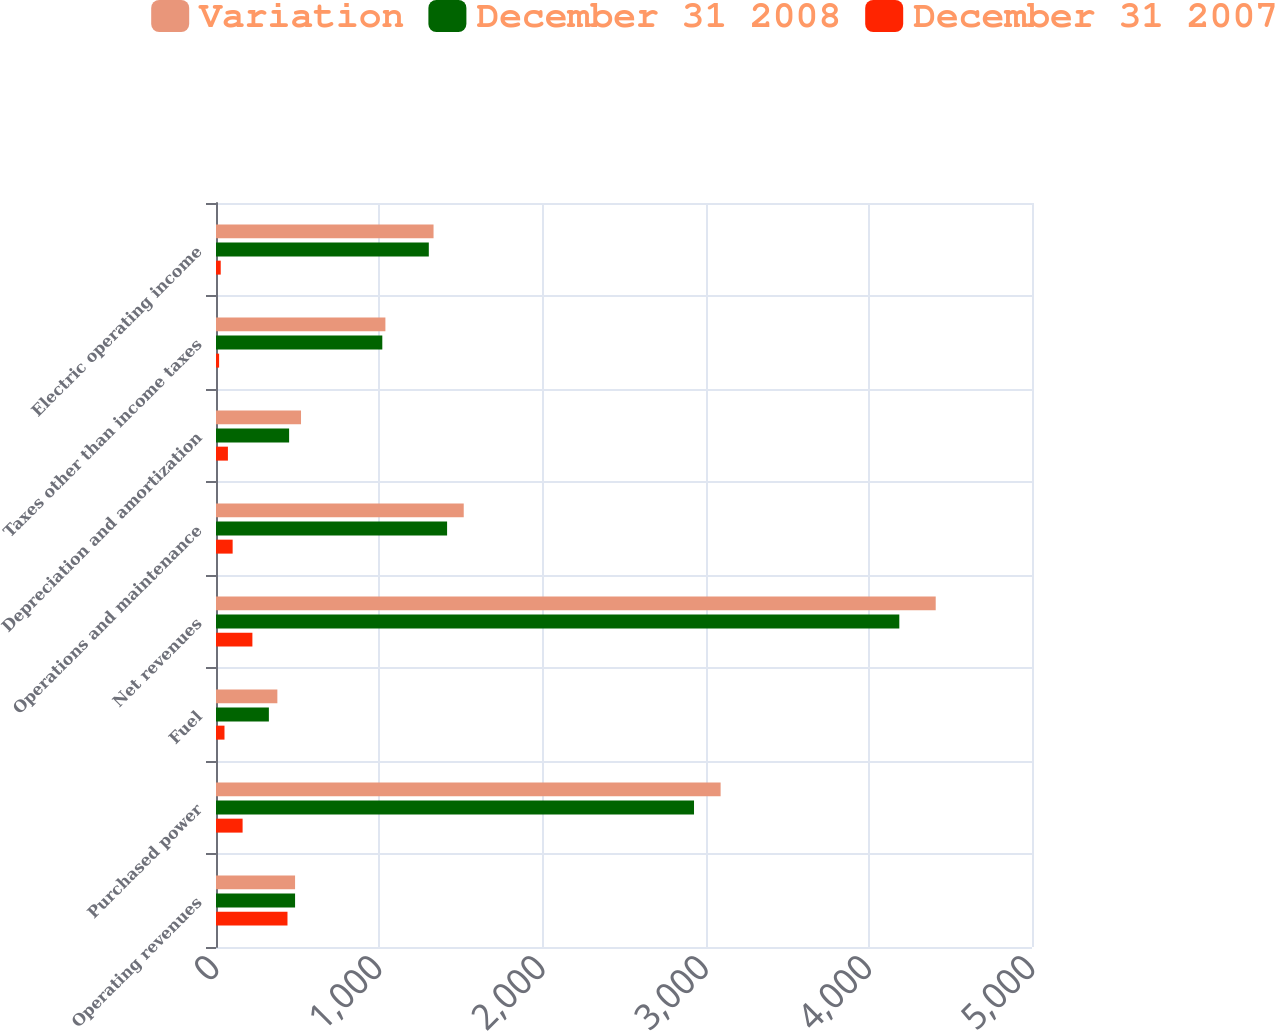Convert chart. <chart><loc_0><loc_0><loc_500><loc_500><stacked_bar_chart><ecel><fcel>Operating revenues<fcel>Purchased power<fcel>Fuel<fcel>Net revenues<fcel>Operations and maintenance<fcel>Depreciation and amortization<fcel>Taxes other than income taxes<fcel>Electric operating income<nl><fcel>Variation<fcel>484.5<fcel>3092<fcel>376<fcel>4410<fcel>1518<fcel>521<fcel>1038<fcel>1333<nl><fcel>December 31 2008<fcel>484.5<fcel>2929<fcel>324<fcel>4187<fcel>1416<fcel>448<fcel>1019<fcel>1304<nl><fcel>December 31 2007<fcel>438<fcel>163<fcel>52<fcel>223<fcel>102<fcel>73<fcel>19<fcel>29<nl></chart> 